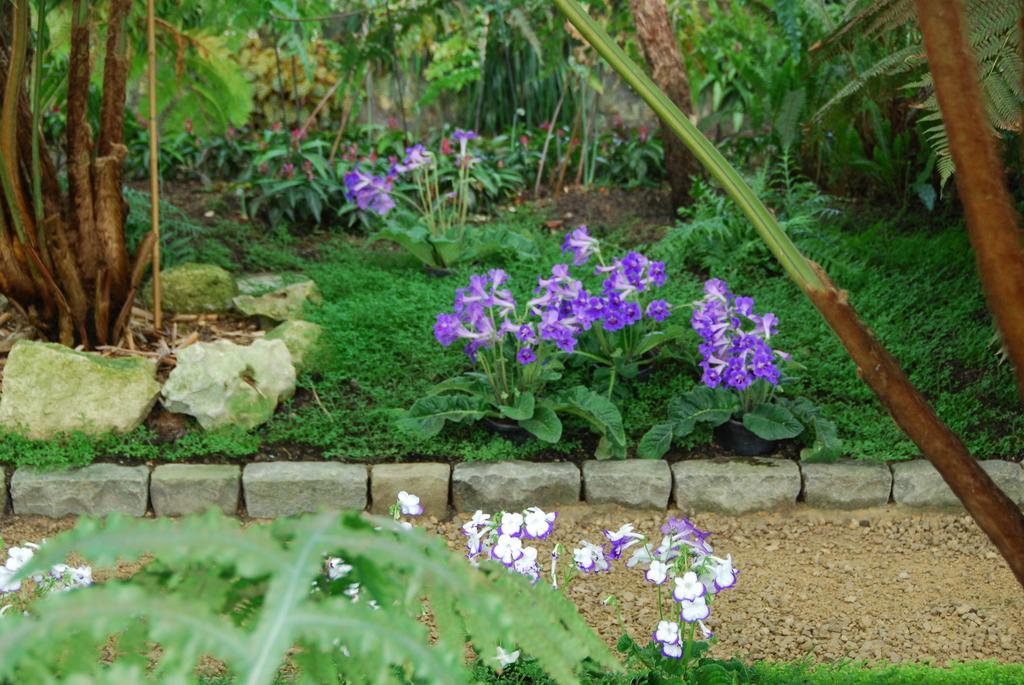Please provide a concise description of this image. In this image, we can see some plants and we can see some flowers. 